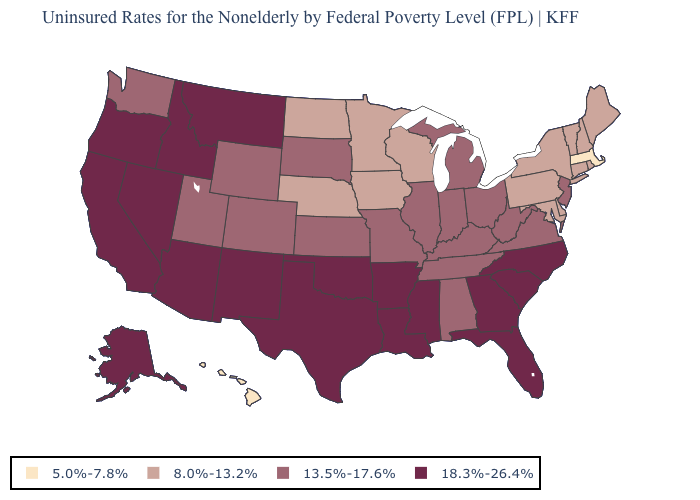Does the map have missing data?
Short answer required. No. What is the lowest value in the USA?
Answer briefly. 5.0%-7.8%. Name the states that have a value in the range 5.0%-7.8%?
Short answer required. Hawaii, Massachusetts. Among the states that border Rhode Island , which have the lowest value?
Be succinct. Massachusetts. What is the highest value in the South ?
Quick response, please. 18.3%-26.4%. Name the states that have a value in the range 5.0%-7.8%?
Write a very short answer. Hawaii, Massachusetts. What is the value of Georgia?
Concise answer only. 18.3%-26.4%. Which states hav the highest value in the MidWest?
Be succinct. Illinois, Indiana, Kansas, Michigan, Missouri, Ohio, South Dakota. Name the states that have a value in the range 18.3%-26.4%?
Quick response, please. Alaska, Arizona, Arkansas, California, Florida, Georgia, Idaho, Louisiana, Mississippi, Montana, Nevada, New Mexico, North Carolina, Oklahoma, Oregon, South Carolina, Texas. What is the value of Colorado?
Give a very brief answer. 13.5%-17.6%. How many symbols are there in the legend?
Keep it brief. 4. What is the value of Minnesota?
Quick response, please. 8.0%-13.2%. Name the states that have a value in the range 8.0%-13.2%?
Answer briefly. Connecticut, Delaware, Iowa, Maine, Maryland, Minnesota, Nebraska, New Hampshire, New York, North Dakota, Pennsylvania, Rhode Island, Vermont, Wisconsin. Name the states that have a value in the range 8.0%-13.2%?
Give a very brief answer. Connecticut, Delaware, Iowa, Maine, Maryland, Minnesota, Nebraska, New Hampshire, New York, North Dakota, Pennsylvania, Rhode Island, Vermont, Wisconsin. Does Oklahoma have the highest value in the USA?
Be succinct. Yes. 